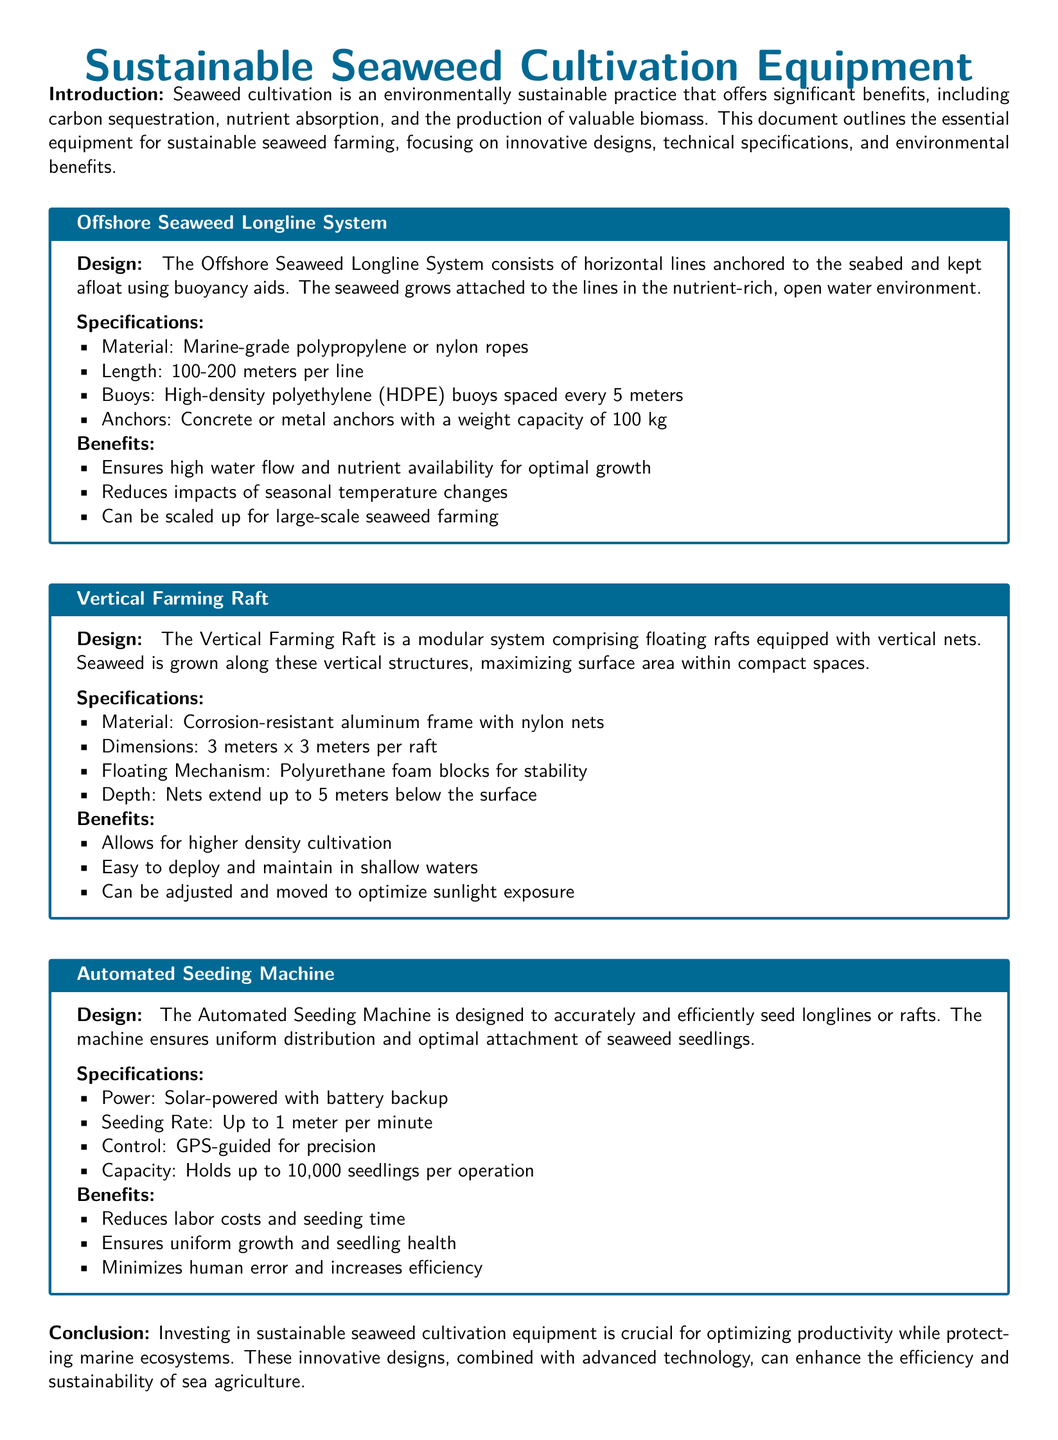What is the material used in the Offshore Seaweed Longline System? The material is marine-grade polypropylene or nylon ropes.
Answer: marine-grade polypropylene or nylon ropes What are the dimensions of the Vertical Farming Raft? The dimensions are specified as 3 meters x 3 meters per raft.
Answer: 3 meters x 3 meters What is the seeding rate of the Automated Seeding Machine? The seeding rate is given as up to 1 meter per minute.
Answer: up to 1 meter per minute What is one benefit of using the Vertical Farming Raft? One of the benefits is that it allows for higher density cultivation.
Answer: higher density cultivation What power source does the Automated Seeding Machine use? The power source is solar-powered with battery backup.
Answer: solar-powered with battery backup What is the specified depth of the nets in the Vertical Farming Raft? The nets extend up to 5 meters below the surface.
Answer: 5 meters How does the Offshore Seaweed Longline System help with temperature changes? It reduces impacts of seasonal temperature changes.
Answer: reduces impacts of seasonal temperature changes What is the maximum capacity of seedlings that the Automated Seeding Machine can hold? The maximum capacity is specified as holds up to 10,000 seedlings per operation.
Answer: holds up to 10,000 seedlings What type of farming does the document focus on? The document focuses on sustainable seaweed farming.
Answer: sustainable seaweed farming What is one key feature of the Offshore Seaweed Longline System? One key feature is that it ensures high water flow and nutrient availability for optimal growth.
Answer: high water flow and nutrient availability for optimal growth 